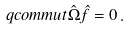<formula> <loc_0><loc_0><loc_500><loc_500>\ q c o m m u t { \hat { \Omega } } { \hat { f } } = 0 \, .</formula> 